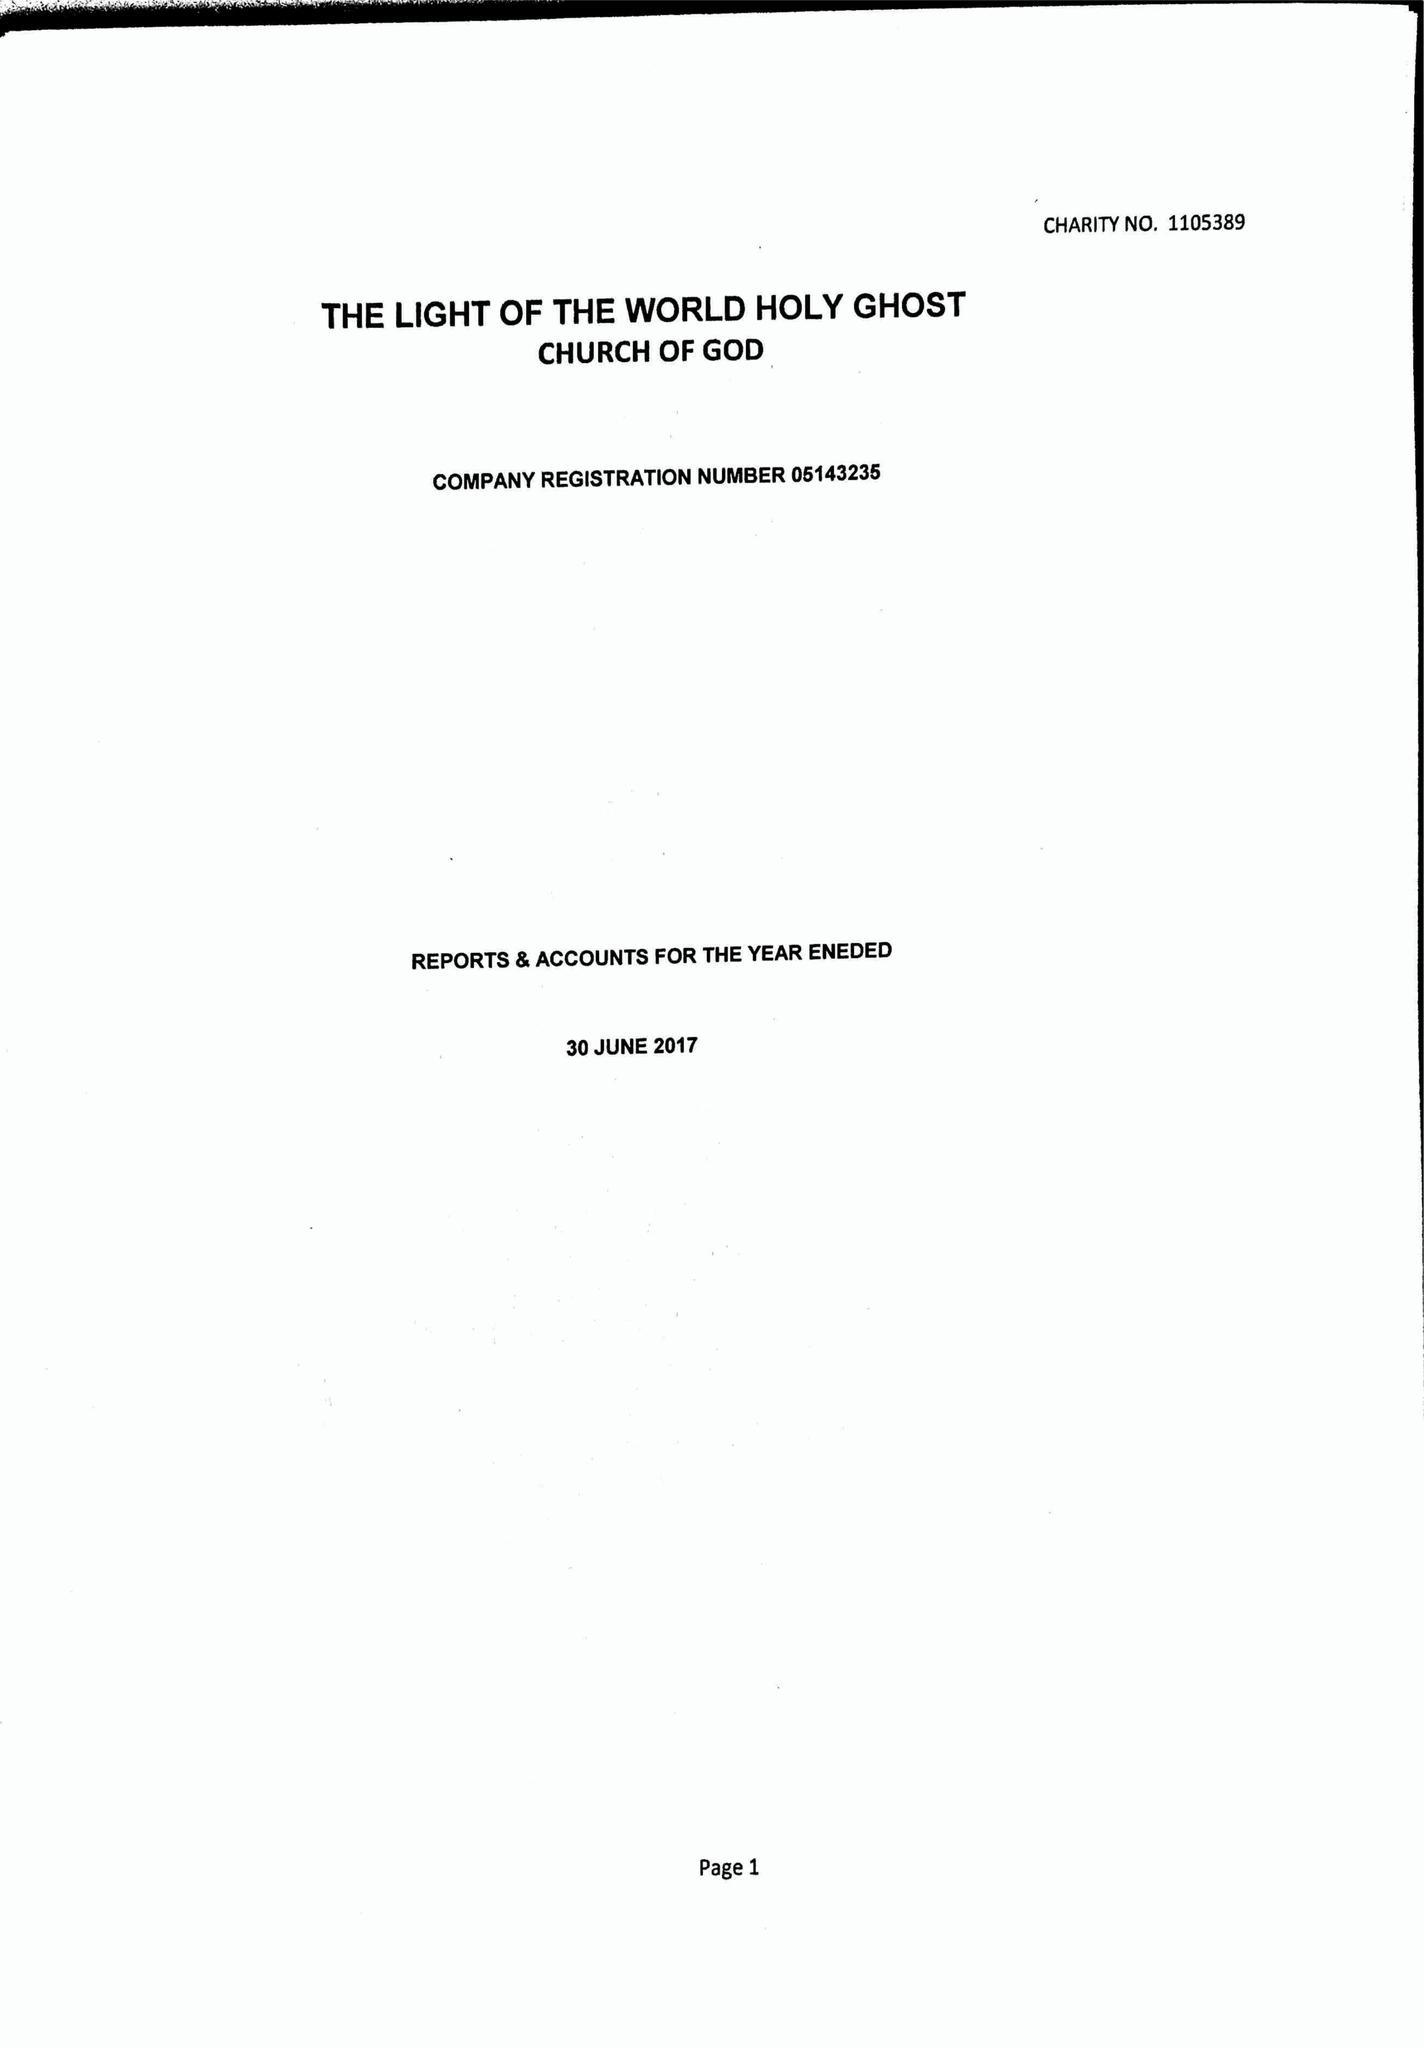What is the value for the charity_name?
Answer the question using a single word or phrase. The Light Of The World Holy Ghost Church Of God 